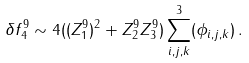Convert formula to latex. <formula><loc_0><loc_0><loc_500><loc_500>\delta f _ { 4 } ^ { 9 } \sim 4 ( ( Z _ { 1 } ^ { 9 } ) ^ { 2 } + Z _ { 2 } ^ { 9 } Z _ { 3 } ^ { 9 } ) \sum _ { i , j , k } ^ { 3 } ( \phi _ { i , j , k } ) \, .</formula> 